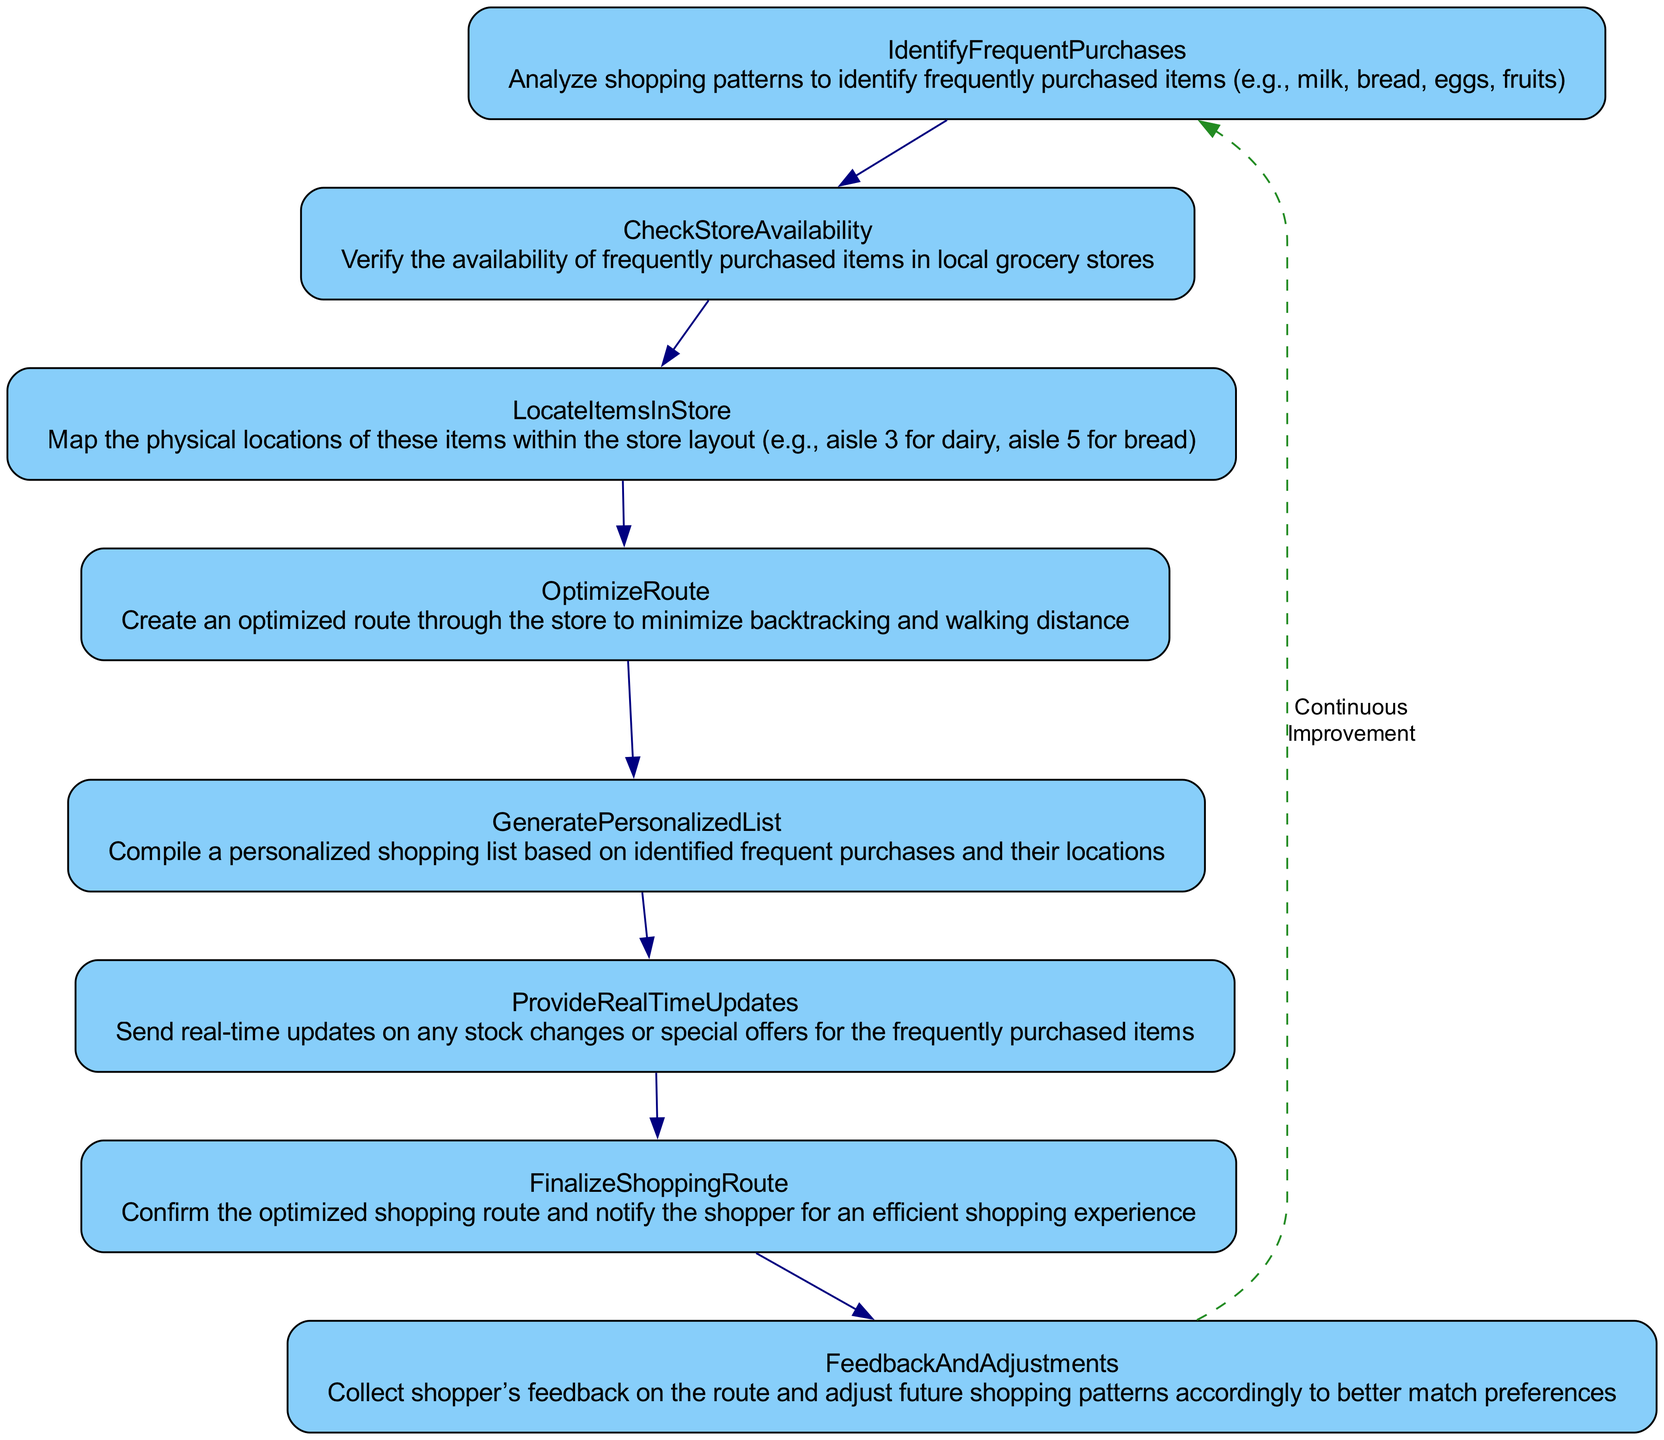What is the first step in the process? The first step is "IdentifyFrequentPurchases," which begins the flow by analyzing shopping patterns.
Answer: IdentifyFrequentPurchases How many nodes are in the diagram? The diagram has 8 distinct nodes, each representing a step in the process.
Answer: 8 What is the last step before finalizing the shopping route? The last step before finalizing the shopping route is "ProvideRealTimeUpdates," which communicates stock changes and offers.
Answer: ProvideRealTimeUpdates Which node provides feedback for future adjustments? The node that provides feedback for future adjustments is "FeedbackAndAdjustments," ensuring continuous improvement of the process.
Answer: FeedbackAndAdjustments What relationship exists between "OptimizeRoute" and "GeneratePersonalizedList"? The relationship is sequential; "OptimizeRoute" comes directly before "GeneratePersonalizedList" in the flowchart.
Answer: Sequential What indicates continuous improvement in the diagram? Continuous improvement is indicated by the dashed edge labeled 'Continuous Improvement' that loops back from "FeedbackAndAdjustments" to "IdentifyFrequentPurchases."
Answer: Continuous Improvement Which step involves mapping item locations? The step that involves mapping item locations is "LocateItemsInStore," which details where items can be found within the store.
Answer: LocateItemsInStore What type of updates are provided in "ProvideRealTimeUpdates"? "ProvideRealTimeUpdates" involves sending real-time updates regarding stock changes or special offers.
Answer: Real-time updates 